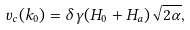<formula> <loc_0><loc_0><loc_500><loc_500>v _ { c } ( k _ { 0 } ) = \delta \gamma ( H _ { 0 } + H _ { a } ) \sqrt { 2 \alpha } ,</formula> 